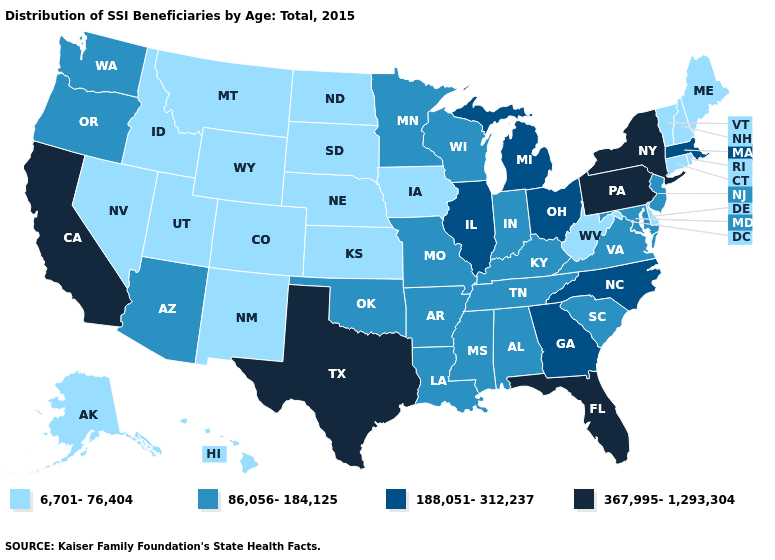What is the value of Maryland?
Be succinct. 86,056-184,125. Which states have the lowest value in the USA?
Concise answer only. Alaska, Colorado, Connecticut, Delaware, Hawaii, Idaho, Iowa, Kansas, Maine, Montana, Nebraska, Nevada, New Hampshire, New Mexico, North Dakota, Rhode Island, South Dakota, Utah, Vermont, West Virginia, Wyoming. Name the states that have a value in the range 6,701-76,404?
Be succinct. Alaska, Colorado, Connecticut, Delaware, Hawaii, Idaho, Iowa, Kansas, Maine, Montana, Nebraska, Nevada, New Hampshire, New Mexico, North Dakota, Rhode Island, South Dakota, Utah, Vermont, West Virginia, Wyoming. Name the states that have a value in the range 86,056-184,125?
Write a very short answer. Alabama, Arizona, Arkansas, Indiana, Kentucky, Louisiana, Maryland, Minnesota, Mississippi, Missouri, New Jersey, Oklahoma, Oregon, South Carolina, Tennessee, Virginia, Washington, Wisconsin. Name the states that have a value in the range 367,995-1,293,304?
Be succinct. California, Florida, New York, Pennsylvania, Texas. What is the lowest value in states that border New Jersey?
Give a very brief answer. 6,701-76,404. Which states hav the highest value in the South?
Keep it brief. Florida, Texas. Does the first symbol in the legend represent the smallest category?
Give a very brief answer. Yes. Which states have the lowest value in the MidWest?
Be succinct. Iowa, Kansas, Nebraska, North Dakota, South Dakota. Does Illinois have a lower value than New York?
Keep it brief. Yes. Name the states that have a value in the range 86,056-184,125?
Write a very short answer. Alabama, Arizona, Arkansas, Indiana, Kentucky, Louisiana, Maryland, Minnesota, Mississippi, Missouri, New Jersey, Oklahoma, Oregon, South Carolina, Tennessee, Virginia, Washington, Wisconsin. Does Wyoming have the lowest value in the West?
Write a very short answer. Yes. Does West Virginia have a lower value than Utah?
Keep it brief. No. Among the states that border Mississippi , which have the highest value?
Give a very brief answer. Alabama, Arkansas, Louisiana, Tennessee. Among the states that border Georgia , which have the lowest value?
Concise answer only. Alabama, South Carolina, Tennessee. 